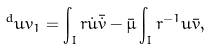<formula> <loc_0><loc_0><loc_500><loc_500>^ { d } u v _ { 1 } = \int _ { I } r \dot { u } \bar { \dot { v } } - \bar { \mu } \int _ { I } r ^ { - 1 } u \bar { v } ,</formula> 